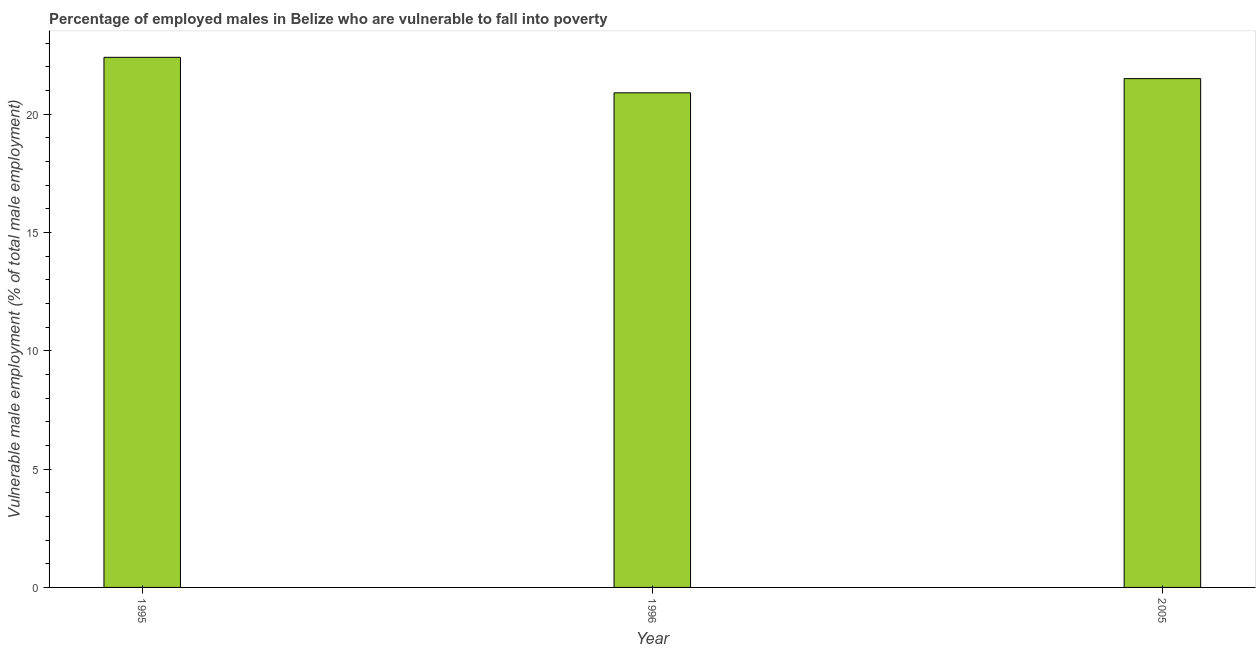Does the graph contain any zero values?
Provide a short and direct response. No. Does the graph contain grids?
Give a very brief answer. No. What is the title of the graph?
Provide a short and direct response. Percentage of employed males in Belize who are vulnerable to fall into poverty. What is the label or title of the X-axis?
Give a very brief answer. Year. What is the label or title of the Y-axis?
Give a very brief answer. Vulnerable male employment (% of total male employment). What is the percentage of employed males who are vulnerable to fall into poverty in 1996?
Keep it short and to the point. 20.9. Across all years, what is the maximum percentage of employed males who are vulnerable to fall into poverty?
Provide a short and direct response. 22.4. Across all years, what is the minimum percentage of employed males who are vulnerable to fall into poverty?
Keep it short and to the point. 20.9. In which year was the percentage of employed males who are vulnerable to fall into poverty maximum?
Offer a very short reply. 1995. What is the sum of the percentage of employed males who are vulnerable to fall into poverty?
Ensure brevity in your answer.  64.8. What is the difference between the percentage of employed males who are vulnerable to fall into poverty in 1995 and 2005?
Provide a short and direct response. 0.9. What is the average percentage of employed males who are vulnerable to fall into poverty per year?
Provide a succinct answer. 21.6. What is the median percentage of employed males who are vulnerable to fall into poverty?
Keep it short and to the point. 21.5. Do a majority of the years between 1996 and 2005 (inclusive) have percentage of employed males who are vulnerable to fall into poverty greater than 3 %?
Keep it short and to the point. Yes. What is the ratio of the percentage of employed males who are vulnerable to fall into poverty in 1995 to that in 1996?
Your answer should be compact. 1.07. Is the difference between the percentage of employed males who are vulnerable to fall into poverty in 1995 and 1996 greater than the difference between any two years?
Your response must be concise. Yes. What is the difference between the highest and the second highest percentage of employed males who are vulnerable to fall into poverty?
Your response must be concise. 0.9. What is the difference between the highest and the lowest percentage of employed males who are vulnerable to fall into poverty?
Give a very brief answer. 1.5. In how many years, is the percentage of employed males who are vulnerable to fall into poverty greater than the average percentage of employed males who are vulnerable to fall into poverty taken over all years?
Keep it short and to the point. 1. How many bars are there?
Give a very brief answer. 3. Are all the bars in the graph horizontal?
Your answer should be very brief. No. Are the values on the major ticks of Y-axis written in scientific E-notation?
Provide a short and direct response. No. What is the Vulnerable male employment (% of total male employment) in 1995?
Your answer should be compact. 22.4. What is the Vulnerable male employment (% of total male employment) of 1996?
Your answer should be compact. 20.9. What is the Vulnerable male employment (% of total male employment) of 2005?
Ensure brevity in your answer.  21.5. What is the difference between the Vulnerable male employment (% of total male employment) in 1996 and 2005?
Keep it short and to the point. -0.6. What is the ratio of the Vulnerable male employment (% of total male employment) in 1995 to that in 1996?
Make the answer very short. 1.07. What is the ratio of the Vulnerable male employment (% of total male employment) in 1995 to that in 2005?
Make the answer very short. 1.04. 